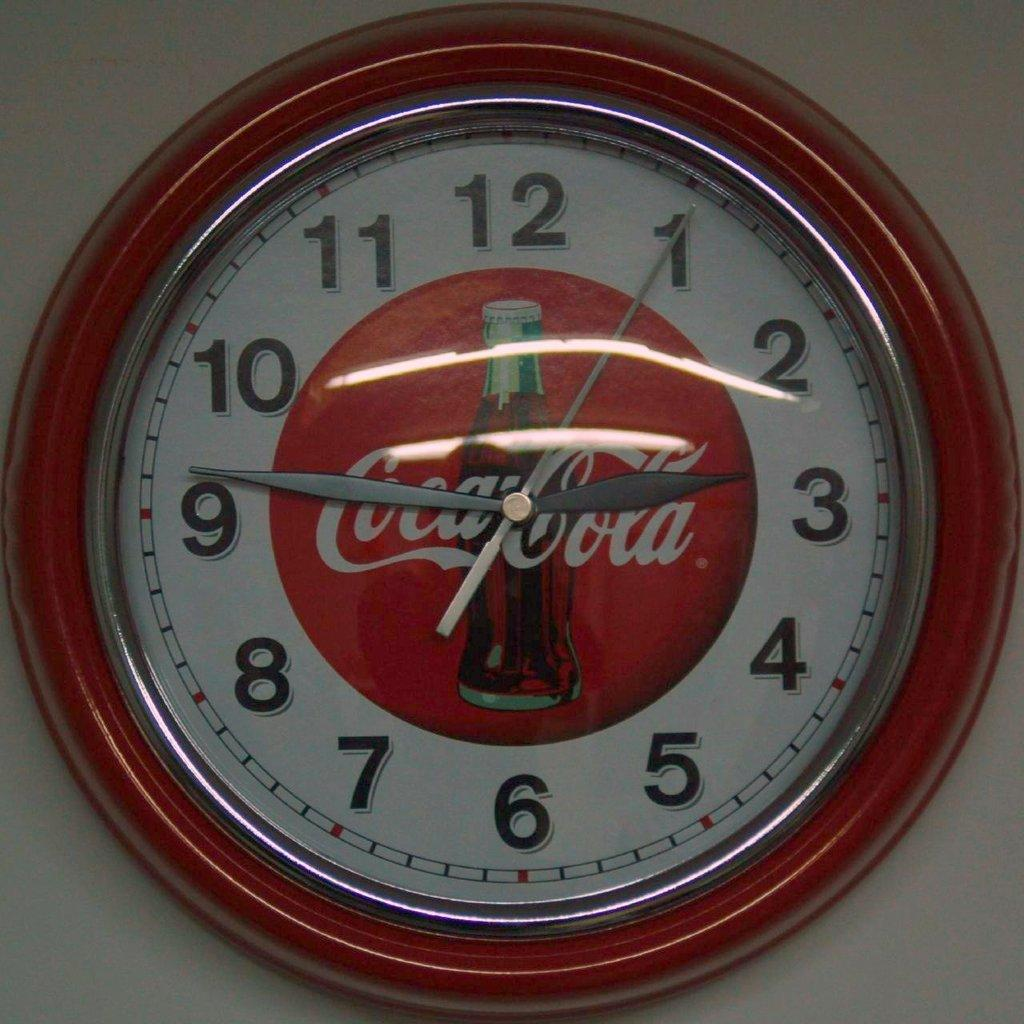<image>
Render a clear and concise summary of the photo. A Coca Cola clock is hanging on a white wall with the time set at 2:46. 